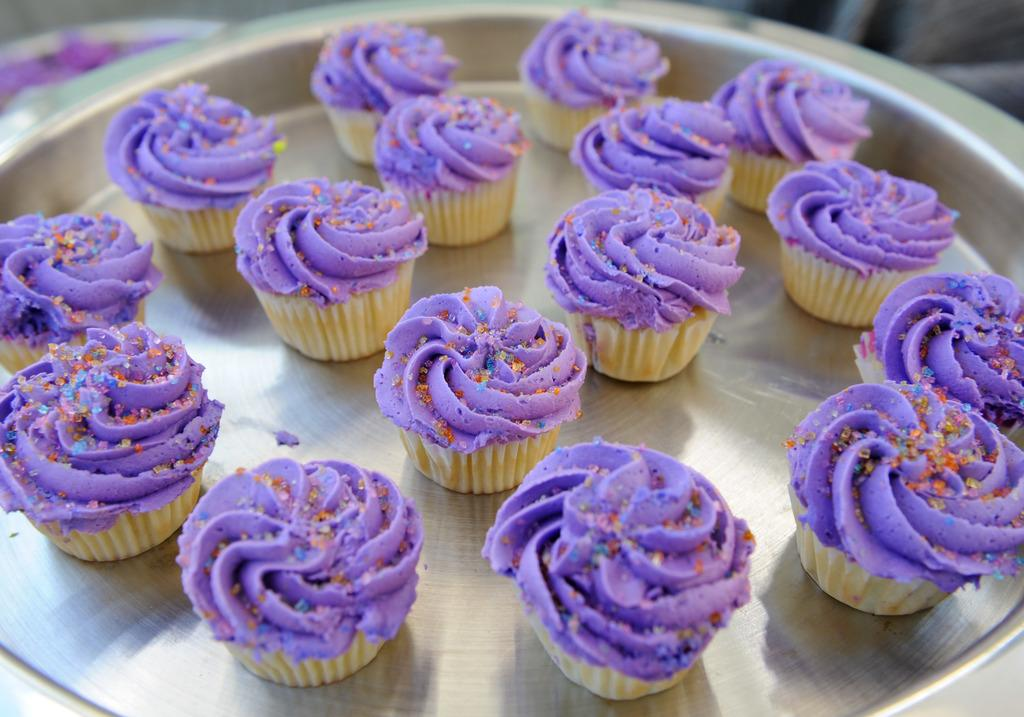What type of dessert can be seen on a plate in the image? There are cupcakes on a plate in the image. Can you describe the background of the image? The background of the image is blurred. What type of yak can be seen grazing in the background of the image? There is no yak present in the image; the background is blurred. What type of butter is used to frost the cupcakes in the image? The image does not provide information about the type of butter used to frost the cupcakes. 